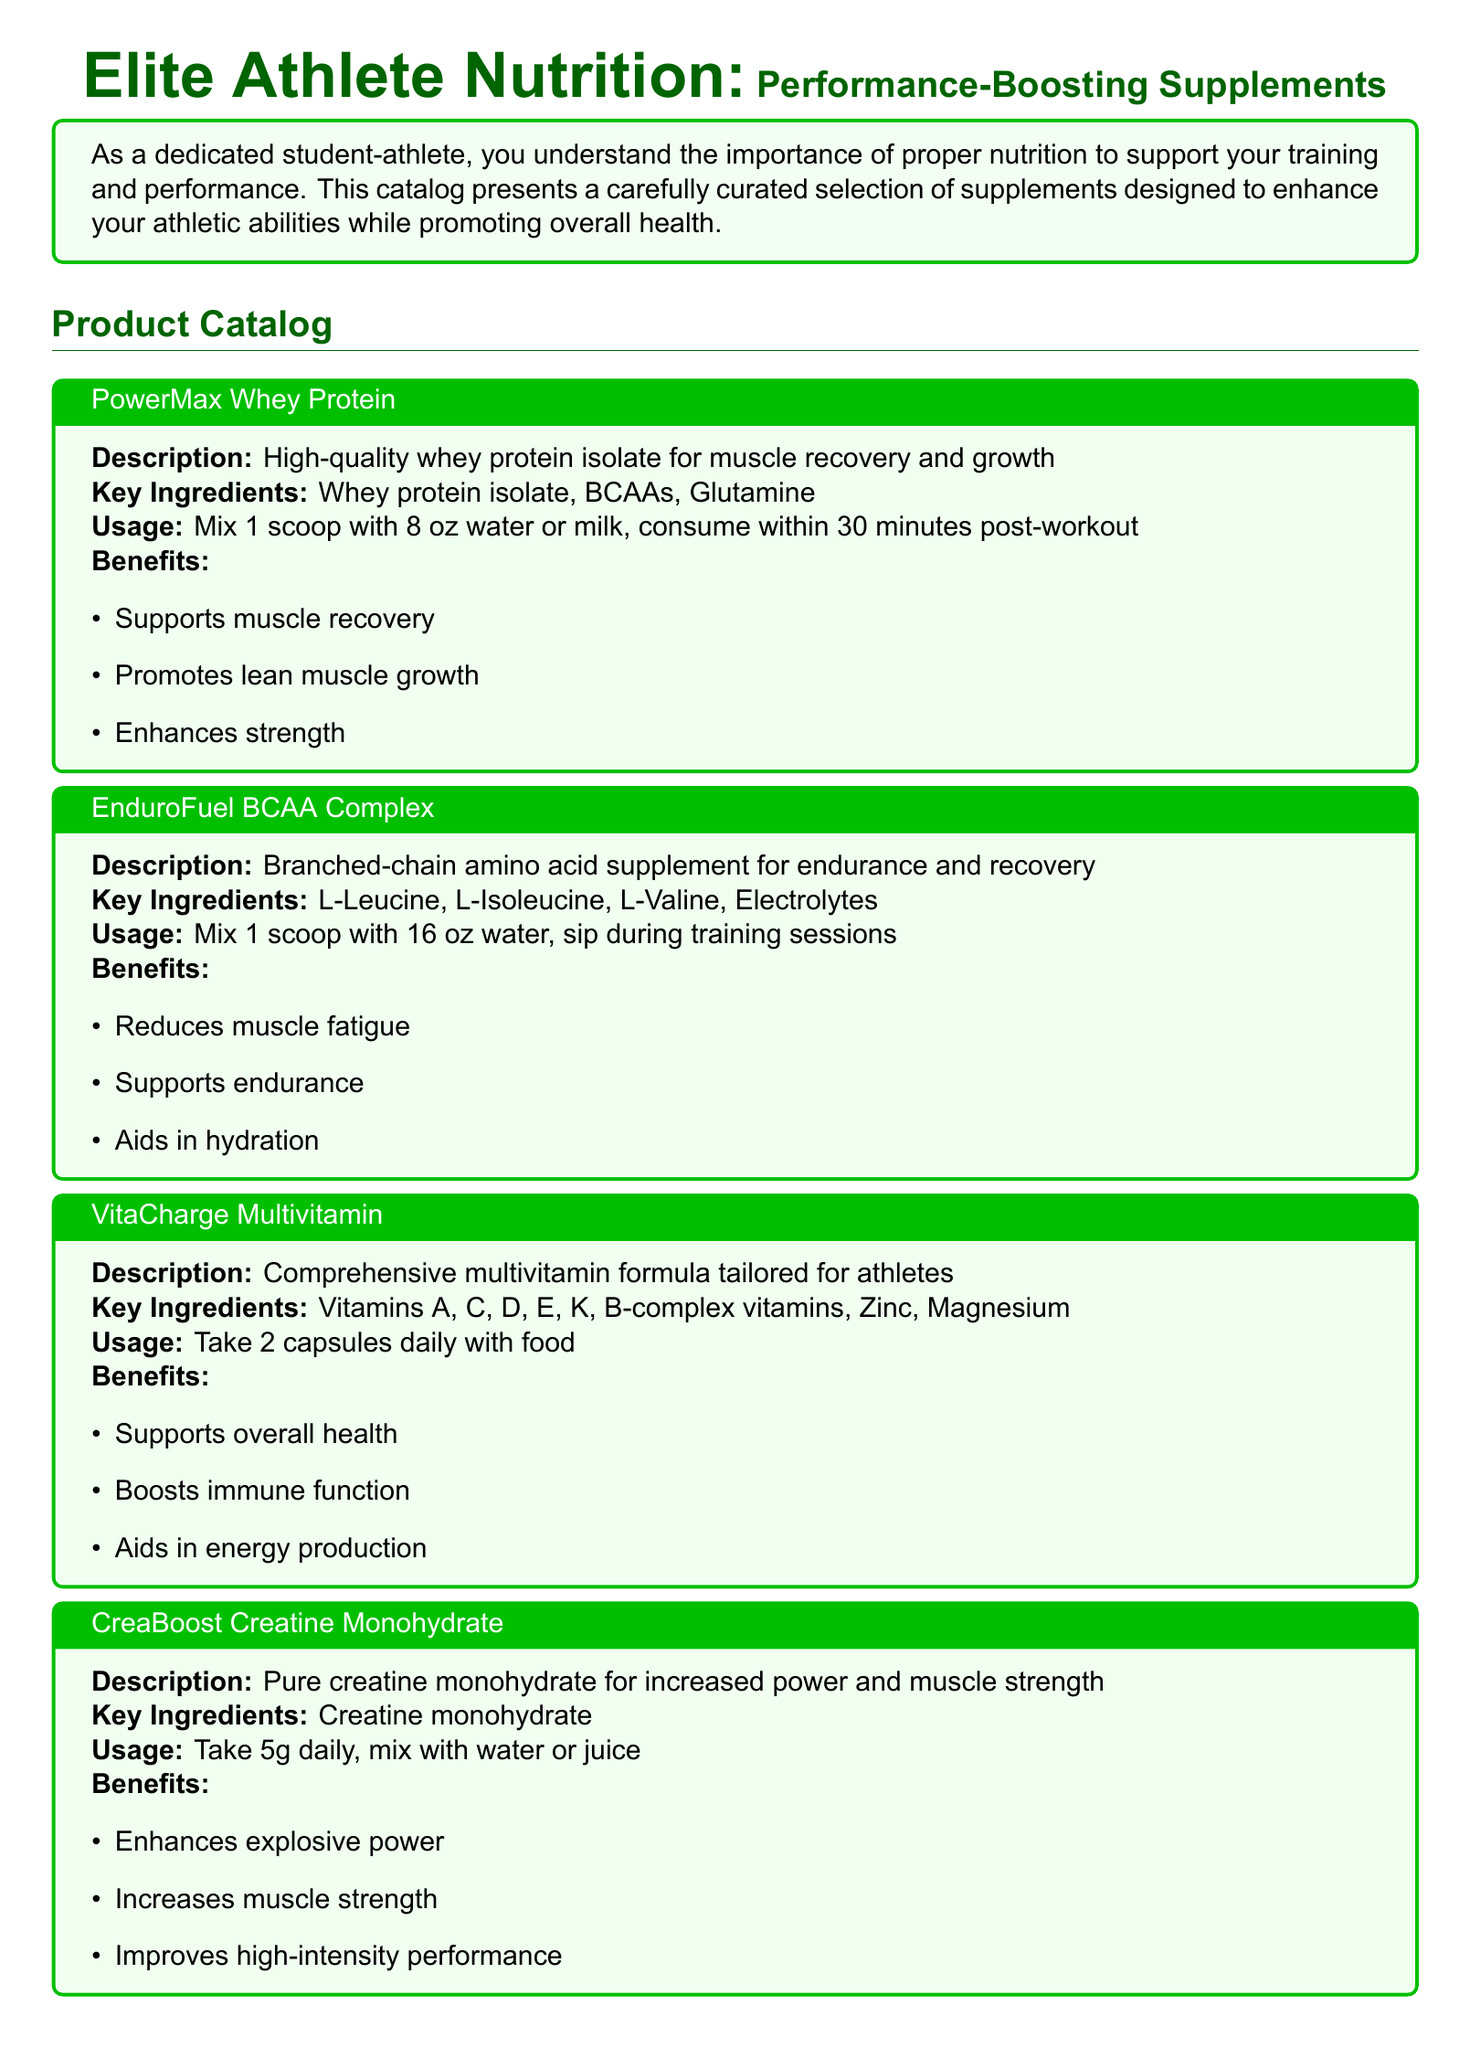What is the title of the catalog? The title of the catalog is prominently displayed at the beginning of the document, which is "Elite Athlete Nutrition: Performance-Boosting Supplements".
Answer: Elite Athlete Nutrition: Performance-Boosting Supplements What is the key ingredient in PowerMax Whey Protein? The key ingredients are listed for each product; for PowerMax Whey Protein, it is "Whey protein isolate".
Answer: Whey protein isolate How should EnduroFuel BCAA Complex be used? The usage instructions for EnduroFuel BCAA Complex are provided, stating to "Mix 1 scoop with 16 oz water, sip during training sessions".
Answer: Mix 1 scoop with 16 oz water, sip during training sessions What are the benefits of VitaCharge Multivitamin? The benefits are outlined in a list format, including "Supports overall health, Boosts immune function, Aids in energy production".
Answer: Supports overall health, Boosts immune function, Aids in energy production What is the recommended daily dosage of CreaBoost Creatine Monohydrate? The document specifies the usage for CreaBoost Creatine Monohydrate as "Take 5g daily".
Answer: Take 5g daily Which product contains electrolytes? The document lists key ingredients for each product; EnduroFuel BCAA Complex includes "Electrolytes" among its key ingredients.
Answer: EnduroFuel BCAA Complex How many capsules of VitaCharge should be taken daily? The usage section for VitaCharge Multivitamin states to "Take 2 capsules daily with food".
Answer: 2 capsules What is the color scheme used in the product description boxes? The color scheme is specified—product description boxes use "productbg" as a background color and "green!75!black" for the border.
Answer: green!75!black What type of supplement is PowerMax Whey Protein categorized as? The product description in the catalog indicates it is a "High-quality whey protein isolate for muscle recovery and growth".
Answer: whey protein isolate 